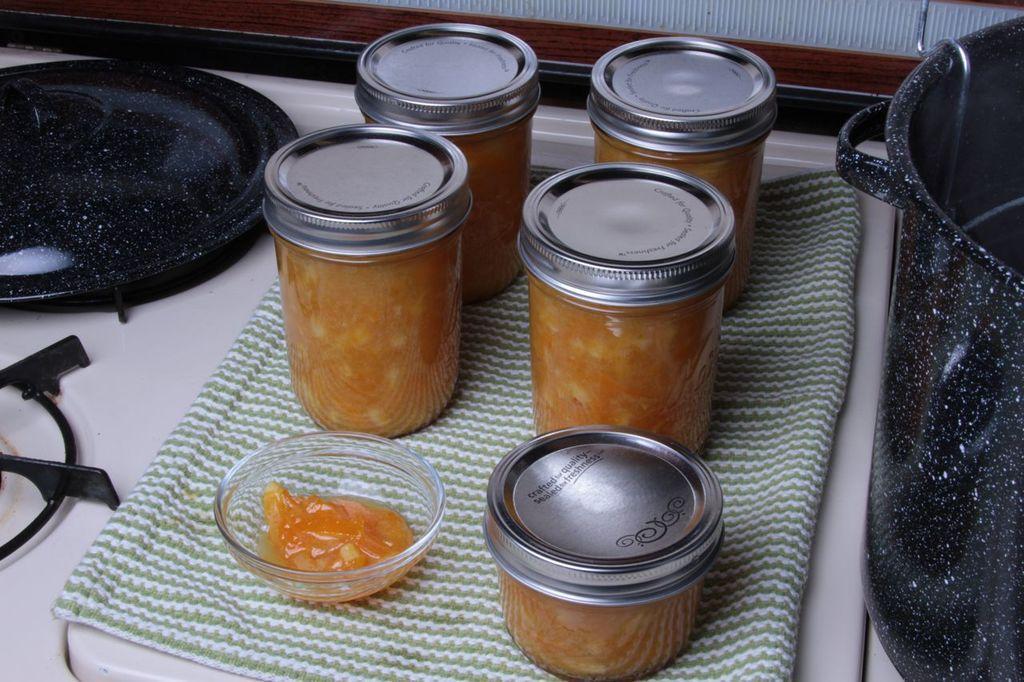Could you give a brief overview of what you see in this image? In this image we can see jars with lids, bowl, napkin, pan, stove and a bowl kept on the white surface. 